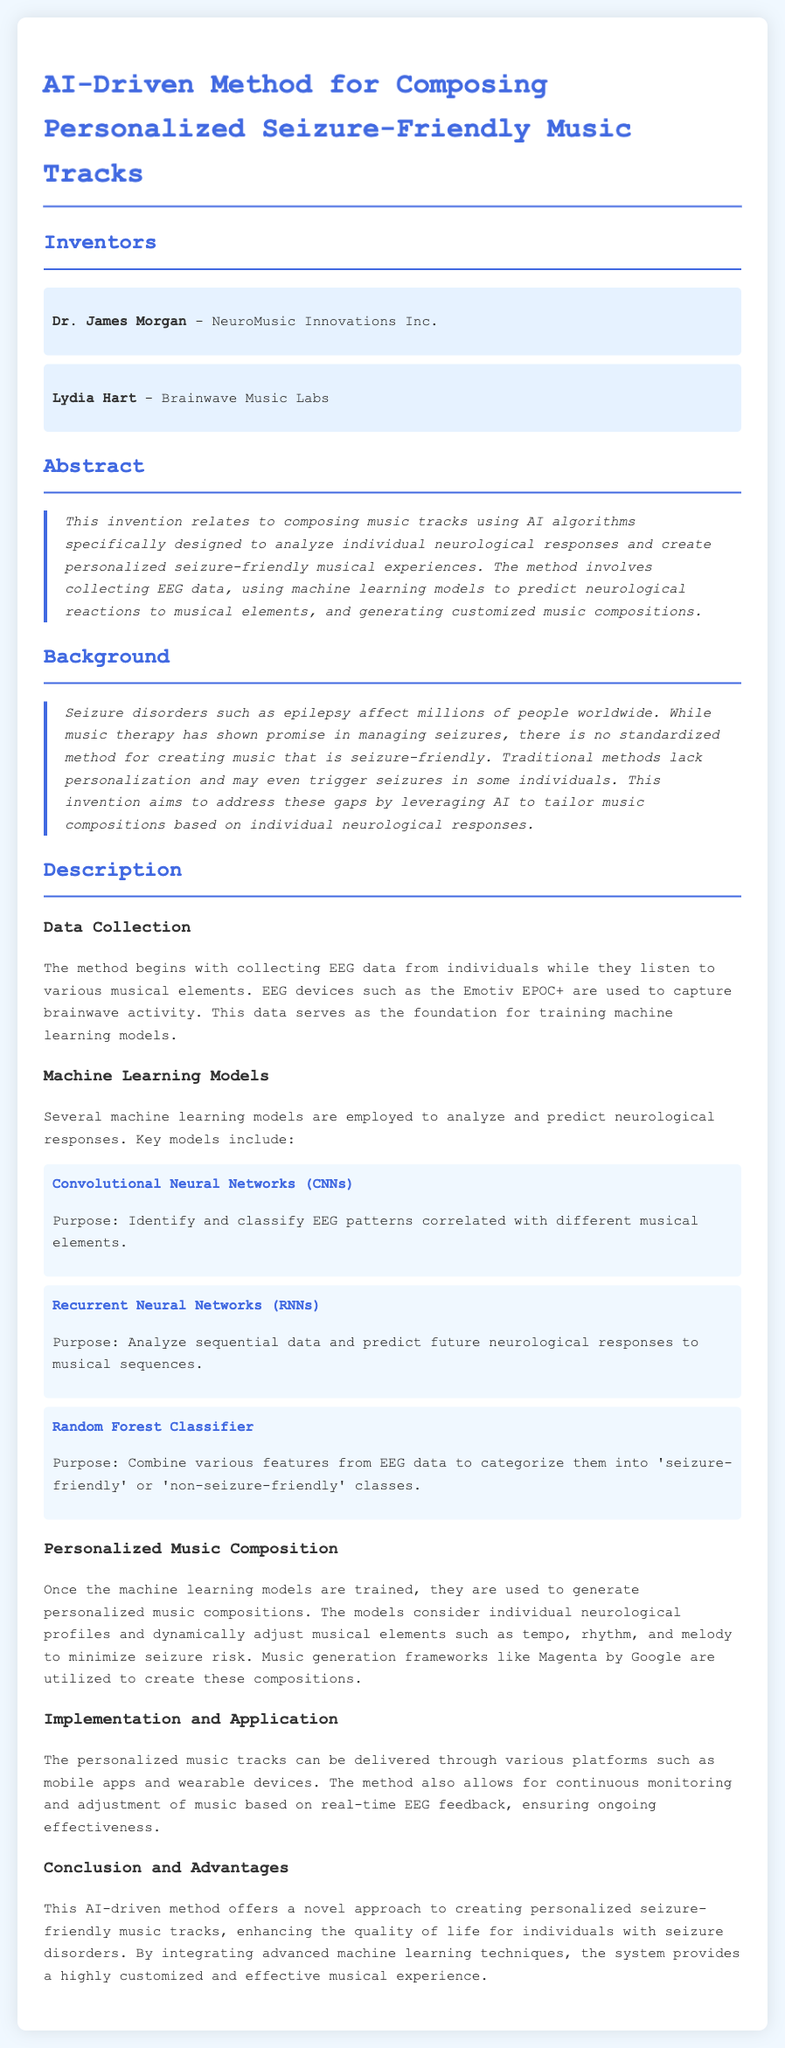What is the title of the patent? The title of the patent is provided at the top of the document.
Answer: AI-Driven Method for Composing Personalized Seizure-Friendly Music Tracks Who are the inventors of this method? The inventors are listed under the "Inventors" section of the document.
Answer: Dr. James Morgan and Lydia Hart What type of data is collected for this method? The type of data collected is mentioned in the "Data Collection" section.
Answer: EEG data Which machine learning model is used to classify EEG patterns? The specific model used for this purpose is detailed in the "Machine Learning Models" section.
Answer: Convolutional Neural Networks (CNNs) What is the purpose of Recurrent Neural Networks in this methodology? The purpose is stated in the "Machine Learning Models" section, describing their function.
Answer: Analyze sequential data and predict future neurological responses What platforms can deliver the personalized music tracks? The platforms for delivering music tracks are mentioned in the "Implementation and Application" section.
Answer: Mobile apps and wearable devices What enhances the quality of life for individuals with seizure disorders? The conclusion mentions the benefits provided by the method.
Answer: This AI-driven method How does the system ensure ongoing effectiveness? The mechanism for ongoing effectiveness is described in the "Implementation and Application" section.
Answer: Continuous monitoring and adjustment of music based on real-time EEG feedback What is the purpose of the Random Forest Classifier in this patent? The purpose of the Random Forest Classifier is detailed in the "Machine Learning Models" section.
Answer: Combine various features from EEG data to categorize them into 'seizure-friendly' or 'non-seizure-friendly' classes 